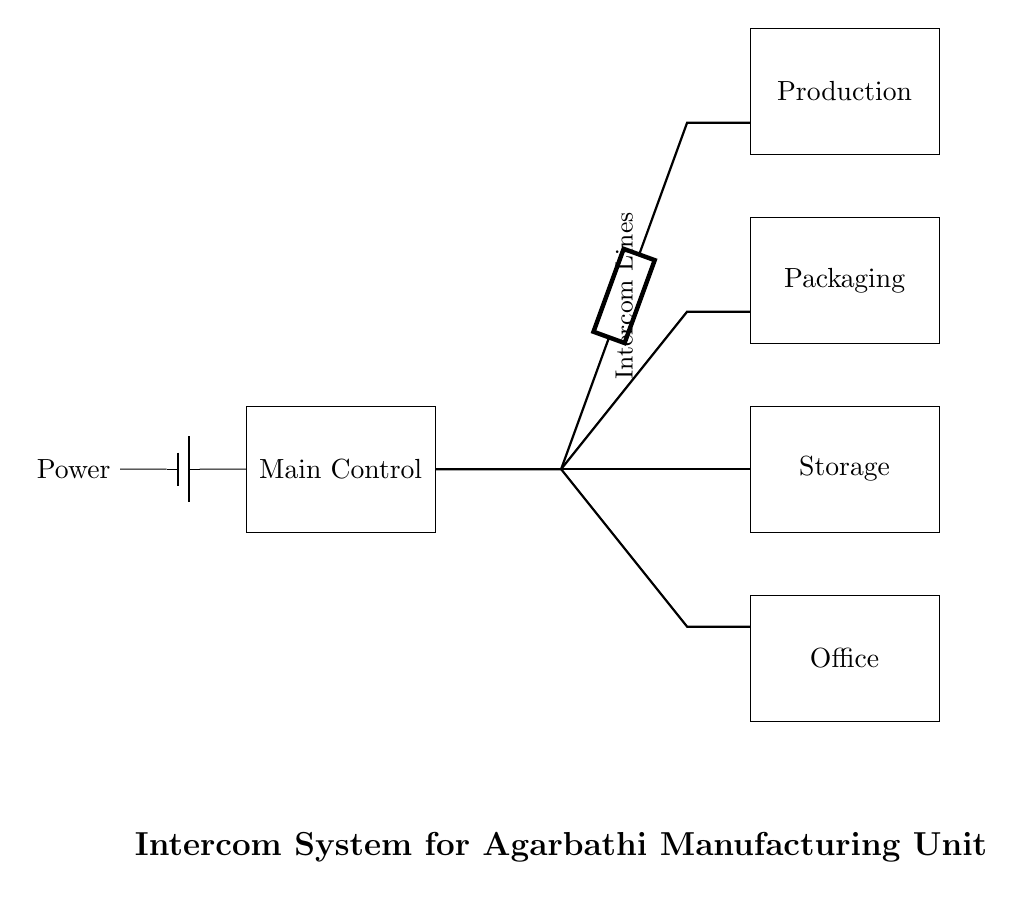What is the main component of the intercom system? The main component is the "Main Control," which acts as the central hub for communication between different sections of the manufacturing unit.
Answer: Main Control How many sections are connected to the intercom system? There are four sections connected: Production, Packaging, Storage, and Office. Each section interacts through the intercom system.
Answer: Four What does the thick line represent in the diagram? The thick lines represent the intercom connections that allow communication between the Main Control unit and different sections of the manufacturing unit.
Answer: Intercom connections What is the power source for the system? The power source is a battery, which is indicated by the battery symbol connected to the Main Control.
Answer: Battery Which section is associated with packaging activities? The section associated with packaging activities is clearly labeled as "Packaging" in the diagram, indicating its specific role within the manufacturing unit's processes.
Answer: Packaging Explain the purpose of the generic component in the circuit. The generic component acts as a transmission medium (like an intercom line) connecting the Main Control with each section, facilitating communication. It's essential for the functionality of the intercom system.
Answer: Transmission medium What is the orientation of the intercom lines according to the diagram? The intercom lines are oriented horizontally, connecting directly from the Main Control unit to the respective sections of the manufacturing unit.
Answer: Horizontally 